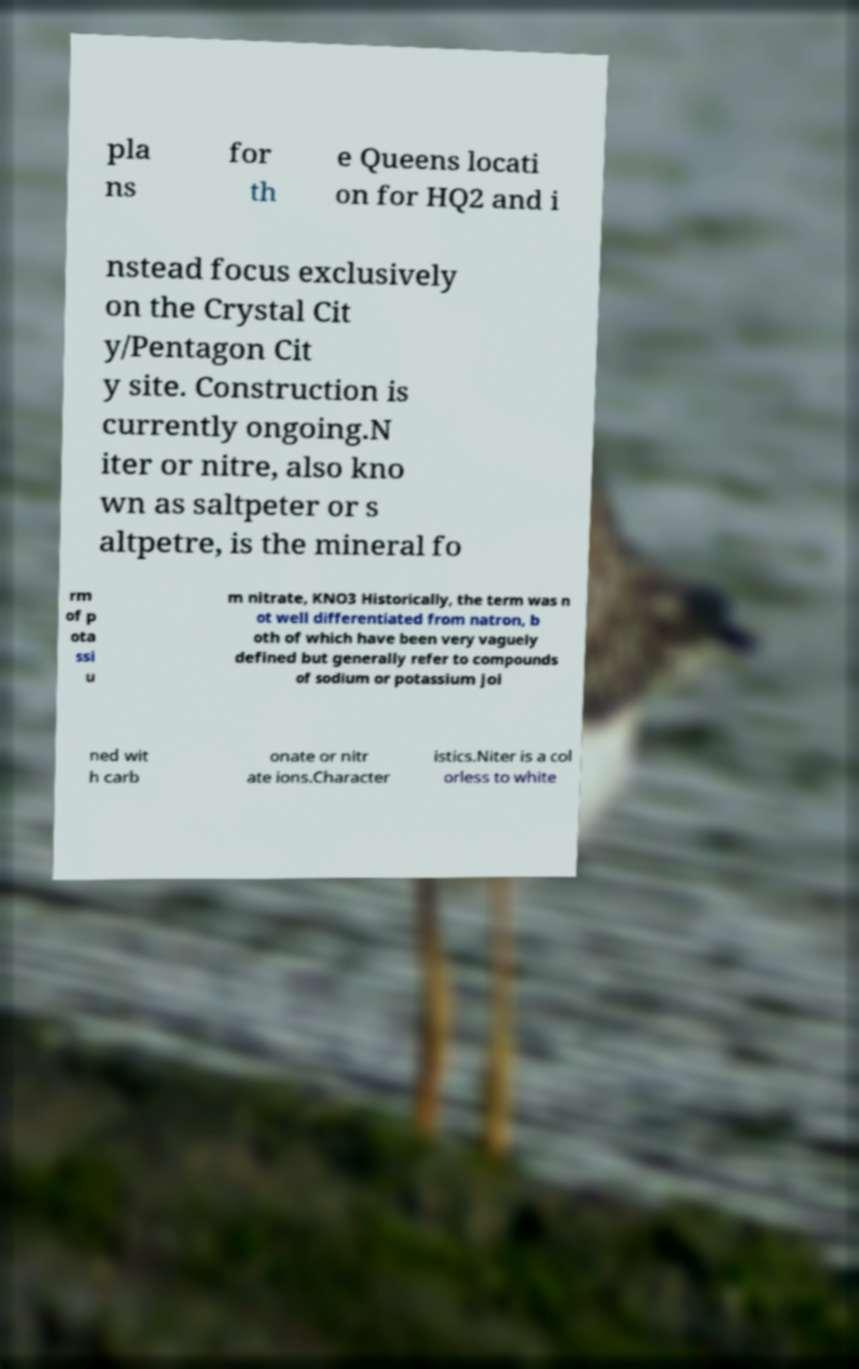There's text embedded in this image that I need extracted. Can you transcribe it verbatim? pla ns for th e Queens locati on for HQ2 and i nstead focus exclusively on the Crystal Cit y/Pentagon Cit y site. Construction is currently ongoing.N iter or nitre, also kno wn as saltpeter or s altpetre, is the mineral fo rm of p ota ssi u m nitrate, KNO3 Historically, the term was n ot well differentiated from natron, b oth of which have been very vaguely defined but generally refer to compounds of sodium or potassium joi ned wit h carb onate or nitr ate ions.Character istics.Niter is a col orless to white 